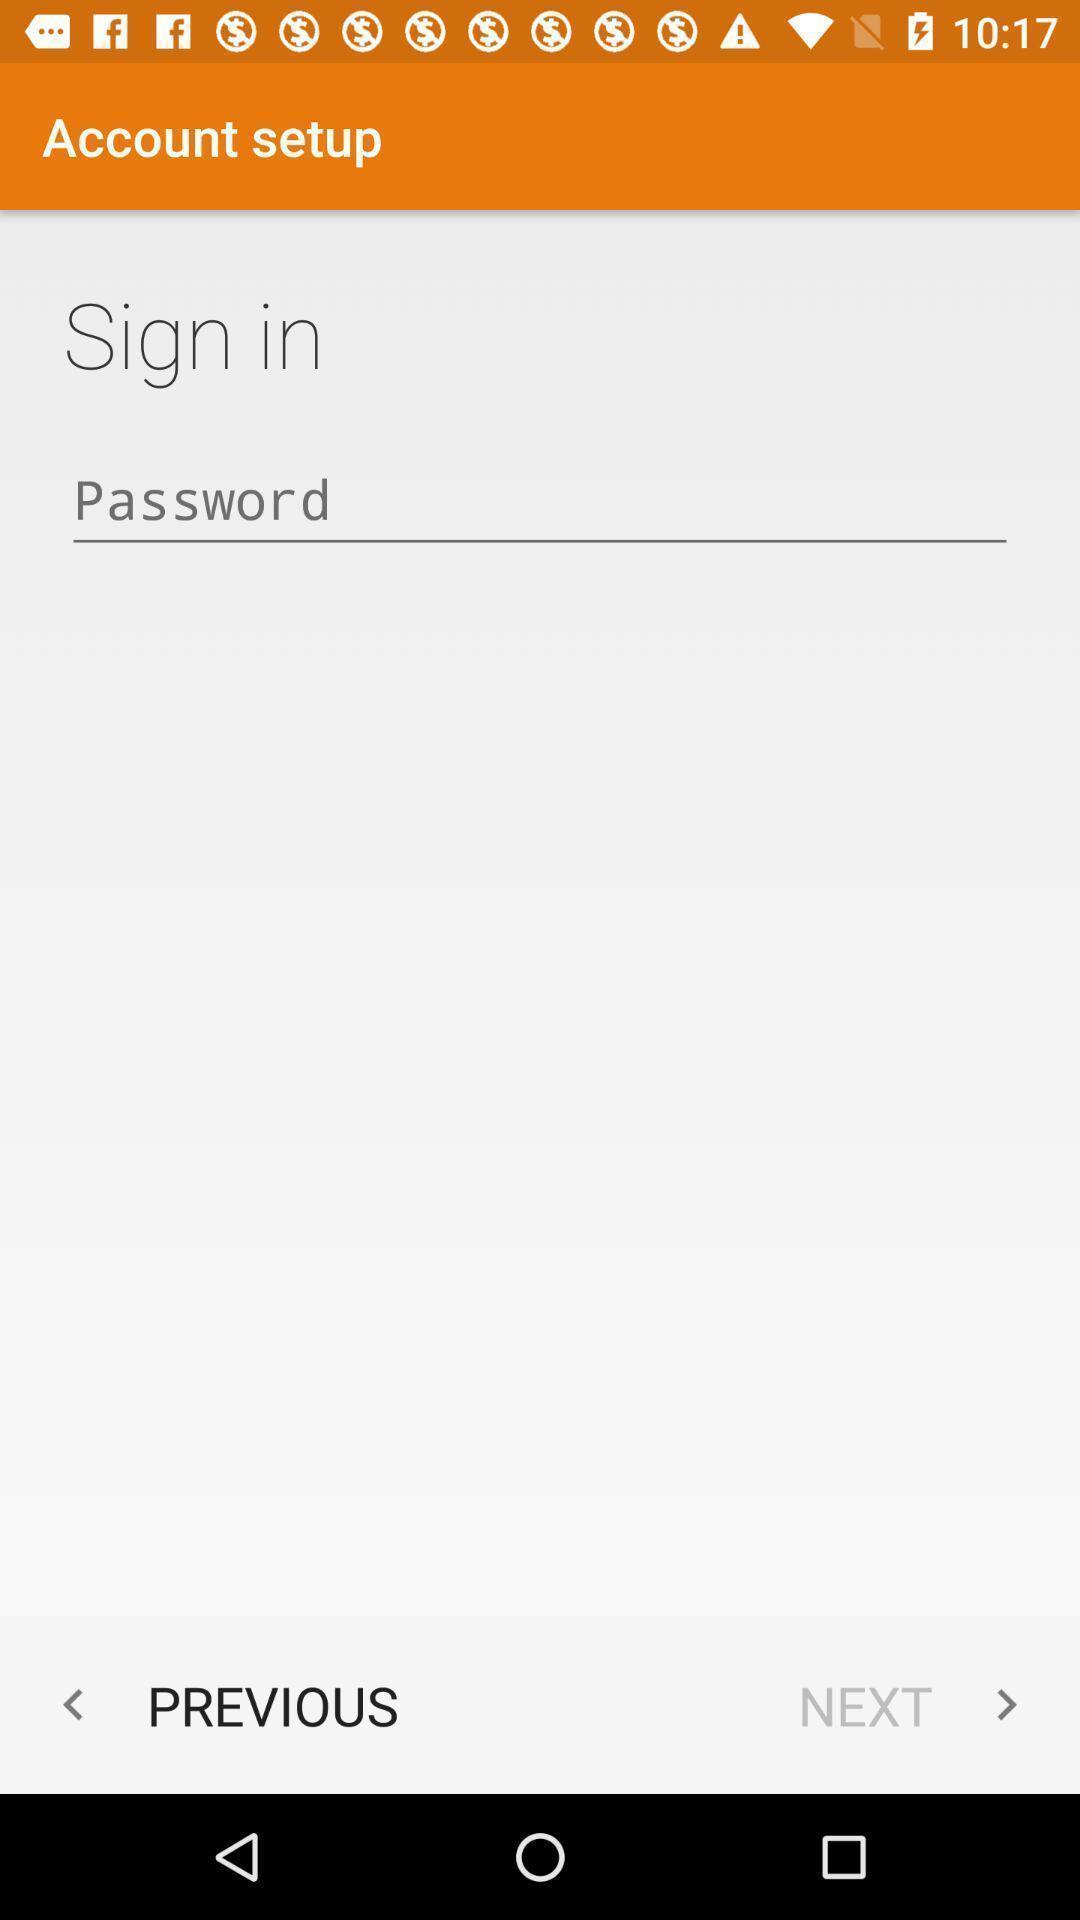What is the overall content of this screenshot? Sign in to setup an account in the application. 